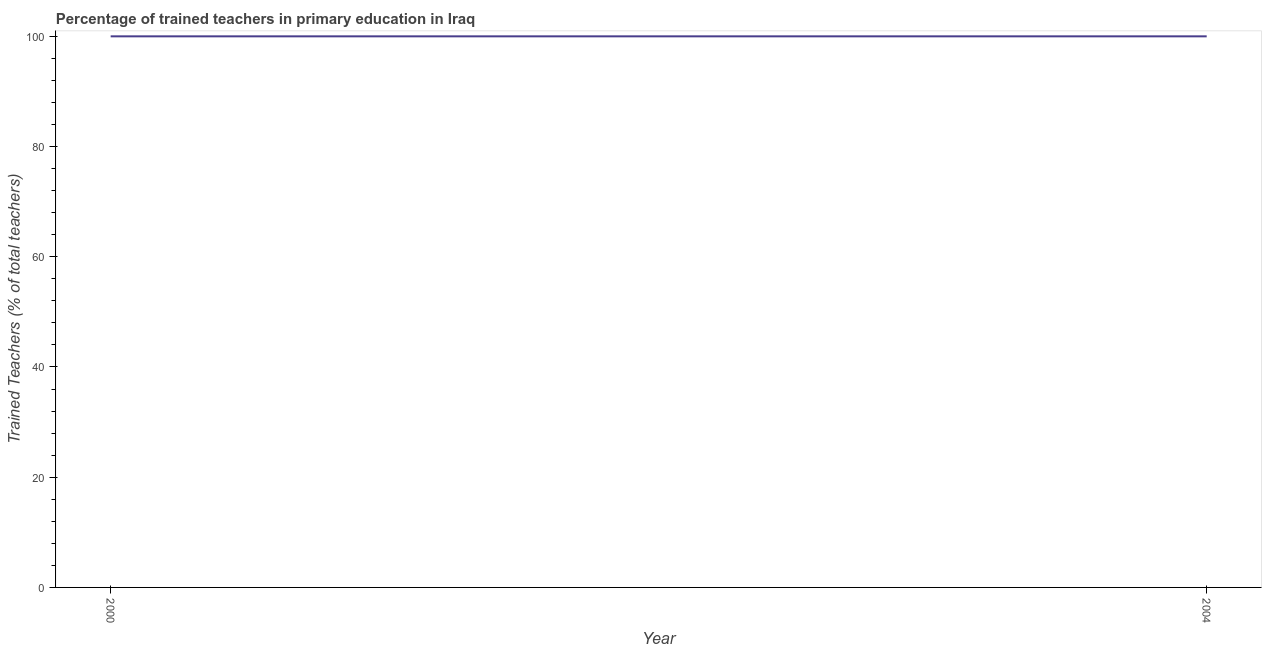What is the percentage of trained teachers in 2000?
Offer a terse response. 100. Across all years, what is the maximum percentage of trained teachers?
Offer a terse response. 100. Across all years, what is the minimum percentage of trained teachers?
Your answer should be compact. 100. In which year was the percentage of trained teachers minimum?
Provide a succinct answer. 2000. What is the sum of the percentage of trained teachers?
Ensure brevity in your answer.  200. What is the difference between the percentage of trained teachers in 2000 and 2004?
Your response must be concise. 0. What is the average percentage of trained teachers per year?
Provide a short and direct response. 100. In how many years, is the percentage of trained teachers greater than 32 %?
Keep it short and to the point. 2. Do a majority of the years between 2004 and 2000 (inclusive) have percentage of trained teachers greater than 32 %?
Provide a short and direct response. No. What is the ratio of the percentage of trained teachers in 2000 to that in 2004?
Give a very brief answer. 1. In how many years, is the percentage of trained teachers greater than the average percentage of trained teachers taken over all years?
Give a very brief answer. 0. How many lines are there?
Provide a short and direct response. 1. What is the title of the graph?
Offer a terse response. Percentage of trained teachers in primary education in Iraq. What is the label or title of the X-axis?
Provide a succinct answer. Year. What is the label or title of the Y-axis?
Make the answer very short. Trained Teachers (% of total teachers). 